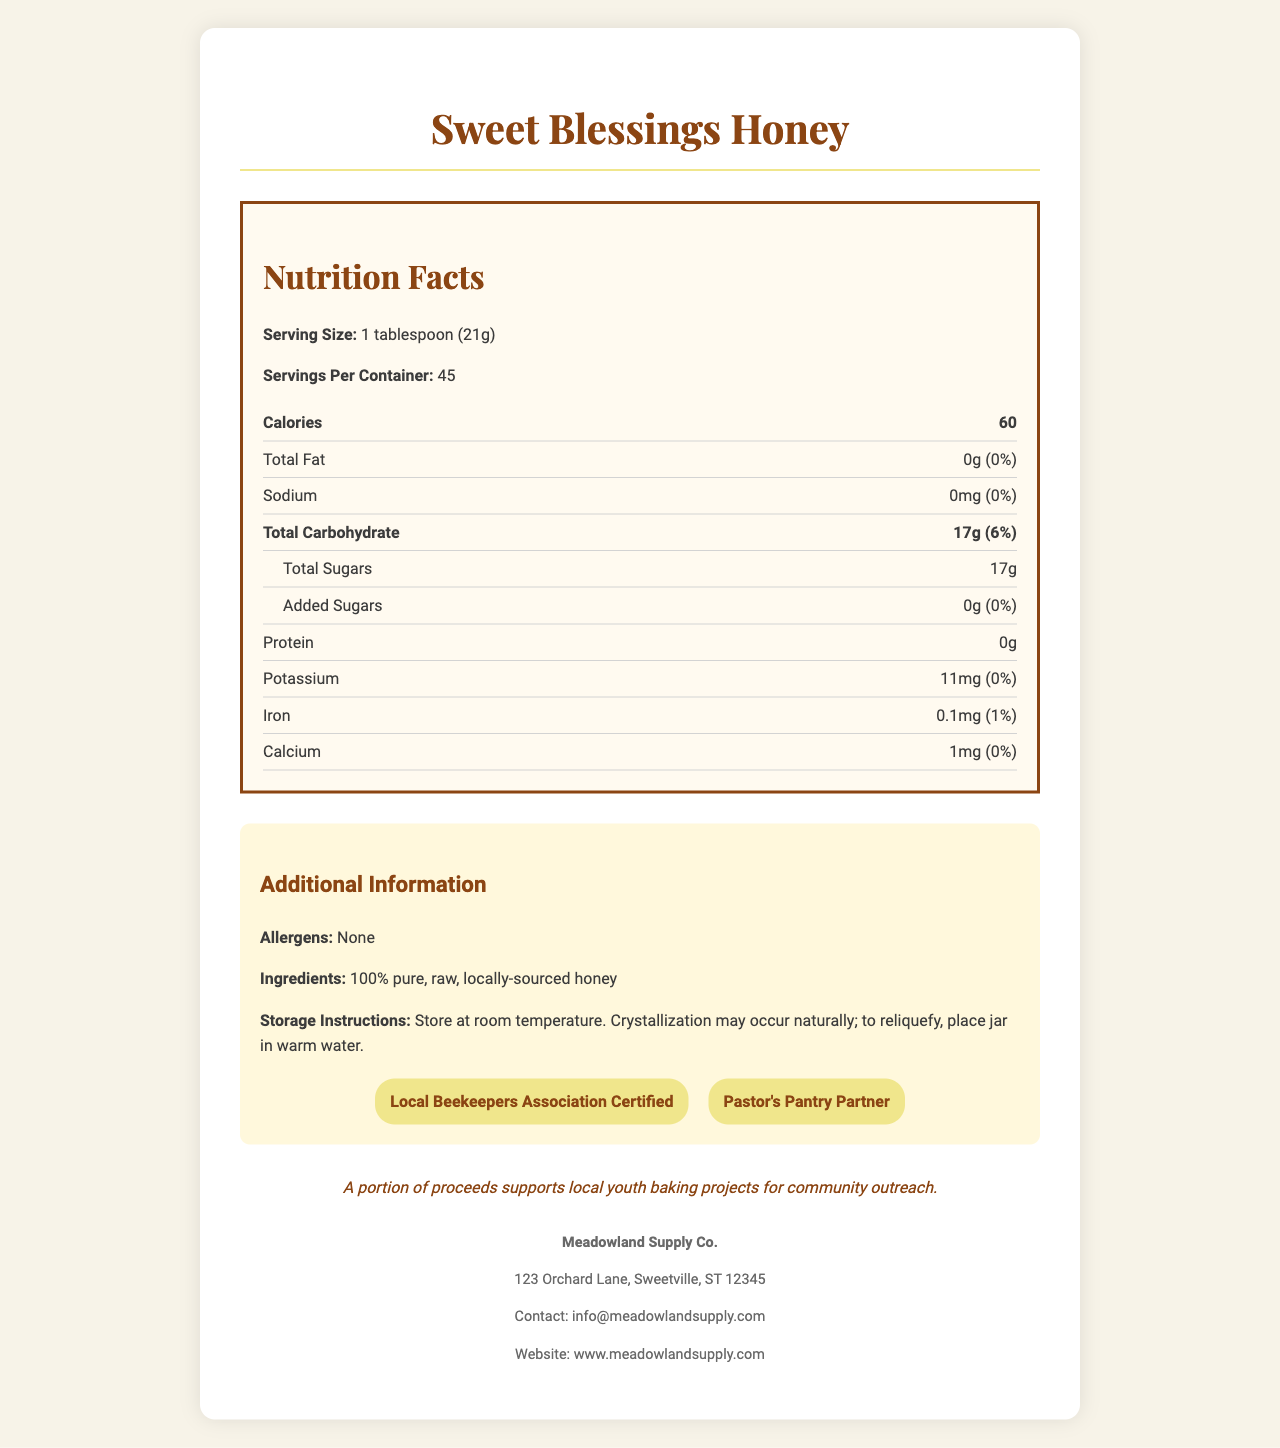what is the serving size for Sweet Blessings Honey? The serving size is explicitly stated as "1 tablespoon (21g)" in the Nutrition Facts Label.
Answer: 1 tablespoon (21g) how many calories are in one serving of Sweet Blessings Honey? The Nutrition Facts Label specifies that each serving contains 60 calories.
Answer: 60 how many total carbohydrates are in a serving? According to the Nutrition Facts Label, one serving contains 17g of total carbohydrates.
Answer: 17g does the product contain any allergens? The additional information section clearly states that the product has no allergens.
Answer: None what certifications does Sweet Blessings Honey have? The certifications listed in the additional information section are "Local Beekeepers Association Certified" and "Pastor's Pantry Partner".
Answer: Local Beekeepers Association Certified, Pastor's Pantry Partner how many servings are in the entire container? A. 30 B. 45 C. 60 The Nutrition Facts label lists "Servings Per Container: 45."
Answer: B. 45 how much protein is in one serving? A. 0g B. 1g C. 2g D. 3g The label specifies that there is 0g of protein per serving.
Answer: A. 0g are there any added sugars in the honey? The added sugars section under total sugars shows "0g (0%)", indicating no added sugars.
Answer: No is there any sodium in a serving of the honey? The sodium content is listed as 0mg (0%).
Answer: No which trace mineral has the highest daily value percentage? A. Potassium B. Iron C. Calcium Iron has the highest daily value percentage at 1%, compared to Potassium (0%) and Calcium (0%).
Answer: B. Iron describe the main idea of this document. The document is structured to give a comprehensive overview of the nutritional content and additional details for Sweet Blessings Honey, including its ingredients, certifications, business information, and charitable note.
Answer: This document provides nutritional information for Sweet Blessings Honey, detailing serving sizes, key nutrients, and additional information such as allergens, ingredients, certifications, and storage instructions. The business info of Meadowland Supply Co. and a charitable note are also included. how much honey is in the entire container? The document does not specify the total quantity of honey in the container.
Answer: Not enough information 